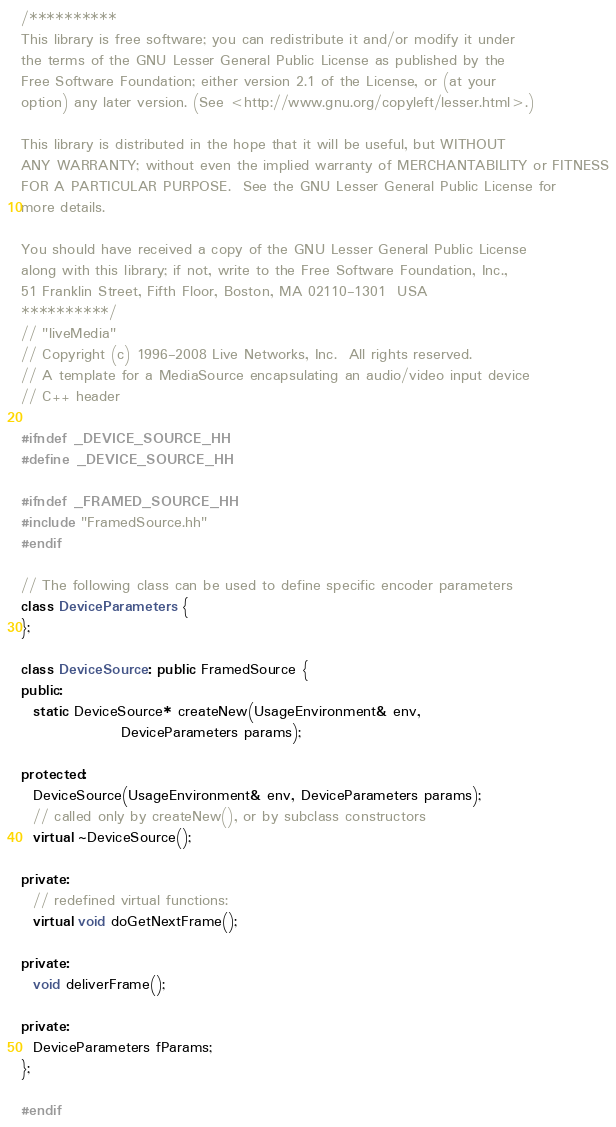<code> <loc_0><loc_0><loc_500><loc_500><_C++_>/**********
This library is free software; you can redistribute it and/or modify it under
the terms of the GNU Lesser General Public License as published by the
Free Software Foundation; either version 2.1 of the License, or (at your
option) any later version. (See <http://www.gnu.org/copyleft/lesser.html>.)

This library is distributed in the hope that it will be useful, but WITHOUT
ANY WARRANTY; without even the implied warranty of MERCHANTABILITY or FITNESS
FOR A PARTICULAR PURPOSE.  See the GNU Lesser General Public License for
more details.

You should have received a copy of the GNU Lesser General Public License
along with this library; if not, write to the Free Software Foundation, Inc.,
51 Franklin Street, Fifth Floor, Boston, MA 02110-1301  USA
**********/
// "liveMedia"
// Copyright (c) 1996-2008 Live Networks, Inc.  All rights reserved.
// A template for a MediaSource encapsulating an audio/video input device
// C++ header

#ifndef _DEVICE_SOURCE_HH
#define _DEVICE_SOURCE_HH

#ifndef _FRAMED_SOURCE_HH
#include "FramedSource.hh"
#endif

// The following class can be used to define specific encoder parameters
class DeviceParameters {
};

class DeviceSource: public FramedSource {
public:
  static DeviceSource* createNew(UsageEnvironment& env,
				 DeviceParameters params);

protected:
  DeviceSource(UsageEnvironment& env, DeviceParameters params);
  // called only by createNew(), or by subclass constructors
  virtual ~DeviceSource();

private:
  // redefined virtual functions:
  virtual void doGetNextFrame();

private:
  void deliverFrame();

private:
  DeviceParameters fParams;
};

#endif
</code> 